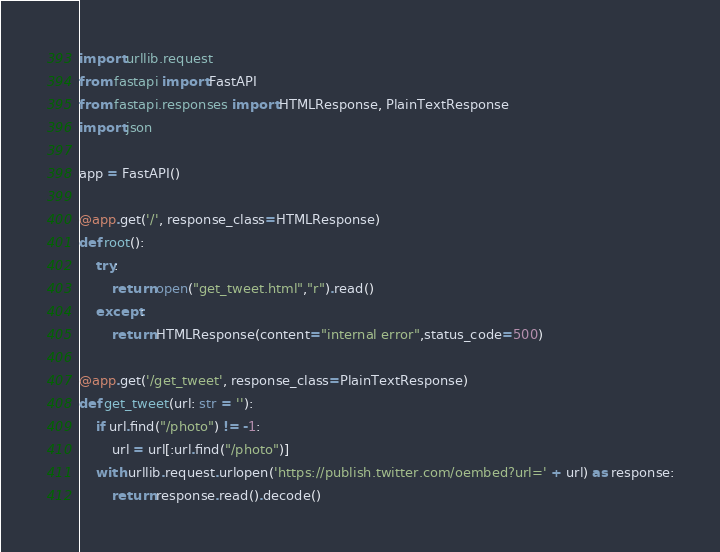<code> <loc_0><loc_0><loc_500><loc_500><_Python_>import urllib.request
from fastapi import FastAPI
from fastapi.responses import HTMLResponse, PlainTextResponse
import json

app = FastAPI()

@app.get('/', response_class=HTMLResponse)
def root():
    try:
        return open("get_tweet.html","r").read()
    except:
        return HTMLResponse(content="internal error",status_code=500)

@app.get('/get_tweet', response_class=PlainTextResponse)
def get_tweet(url: str = ''):
    if url.find("/photo") != -1:
        url = url[:url.find("/photo")]
    with urllib.request.urlopen('https://publish.twitter.com/oembed?url=' + url) as response:
        return response.read().decode()

</code> 